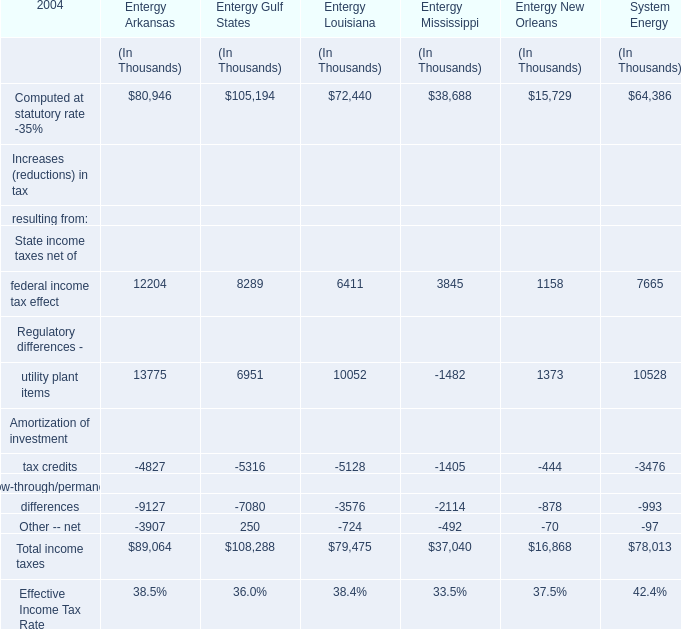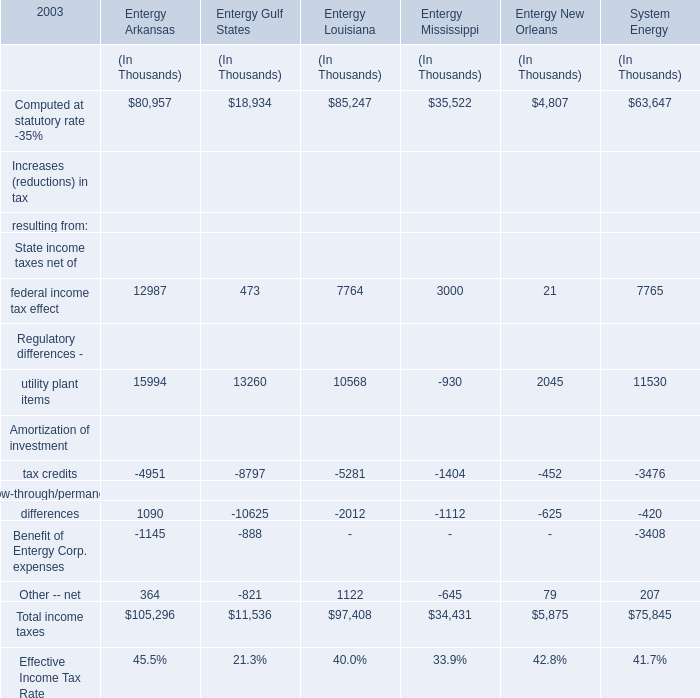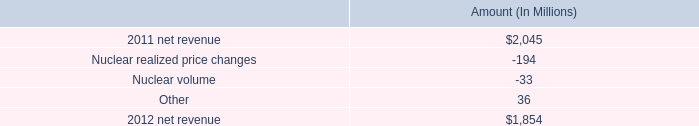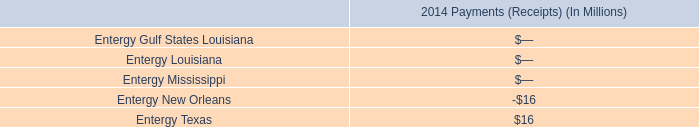What is the percentage of all income taxes that are positive to the total amount, for Entergy Arkansas? 
Computations: (((((80957 + 12987) + 15994) + 1090) + 364) / 105296)
Answer: 1.05789. 